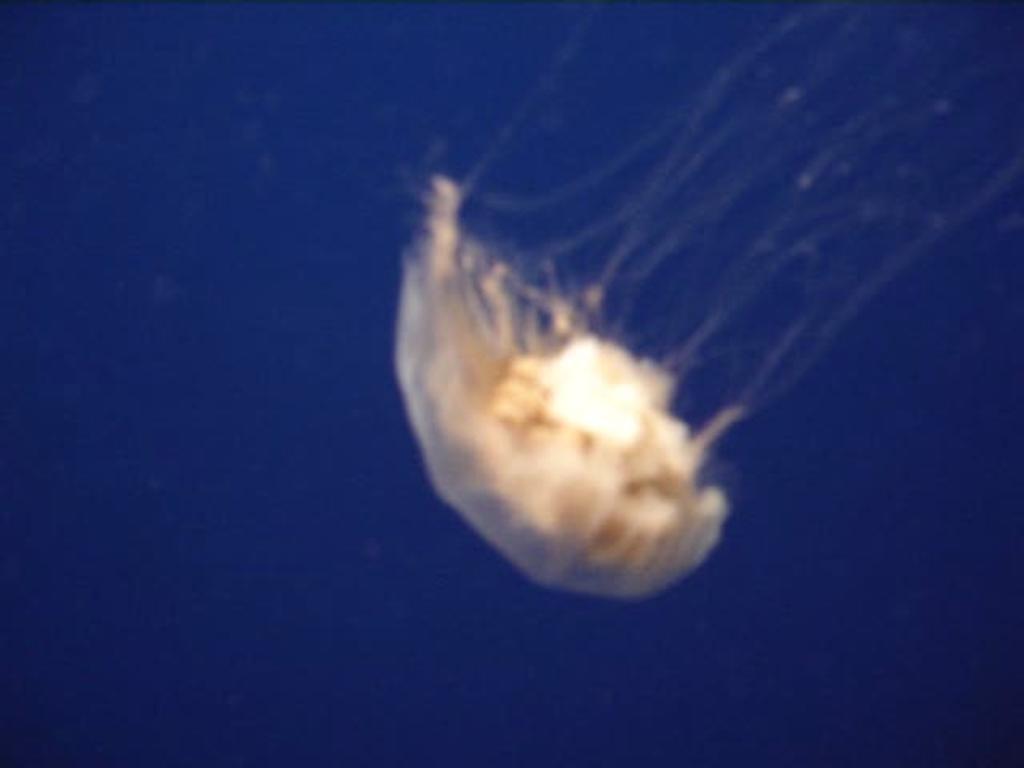What is the main object in the image? There is a sky lantern in the image. What is the color of the sky in the image? The sky is clear and blue in the image. What is the purpose of the stem in the image? There is no stem present in the image; the main object is a sky lantern. 